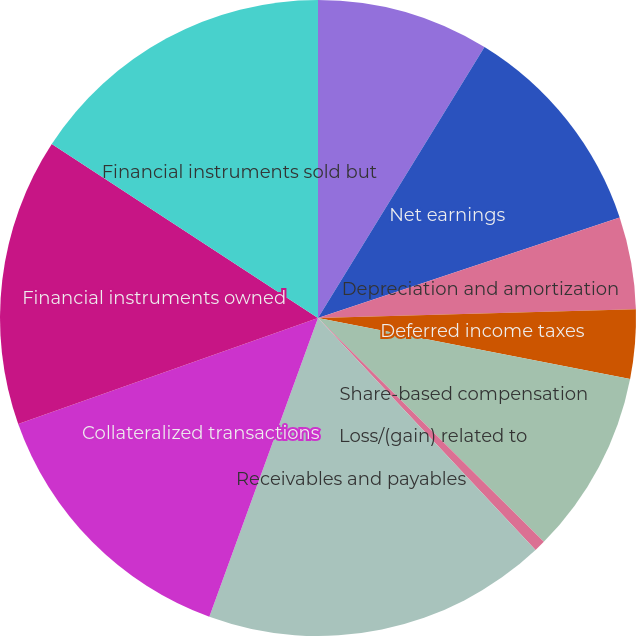Convert chart. <chart><loc_0><loc_0><loc_500><loc_500><pie_chart><fcel>in millions<fcel>Net earnings<fcel>Depreciation and amortization<fcel>Deferred income taxes<fcel>Share-based compensation<fcel>Loss/(gain) related to<fcel>Receivables and payables<fcel>Collateralized transactions<fcel>Financial instruments owned<fcel>Financial instruments sold but<nl><fcel>8.77%<fcel>11.11%<fcel>4.68%<fcel>3.51%<fcel>9.36%<fcel>0.58%<fcel>17.54%<fcel>14.04%<fcel>14.62%<fcel>15.79%<nl></chart> 